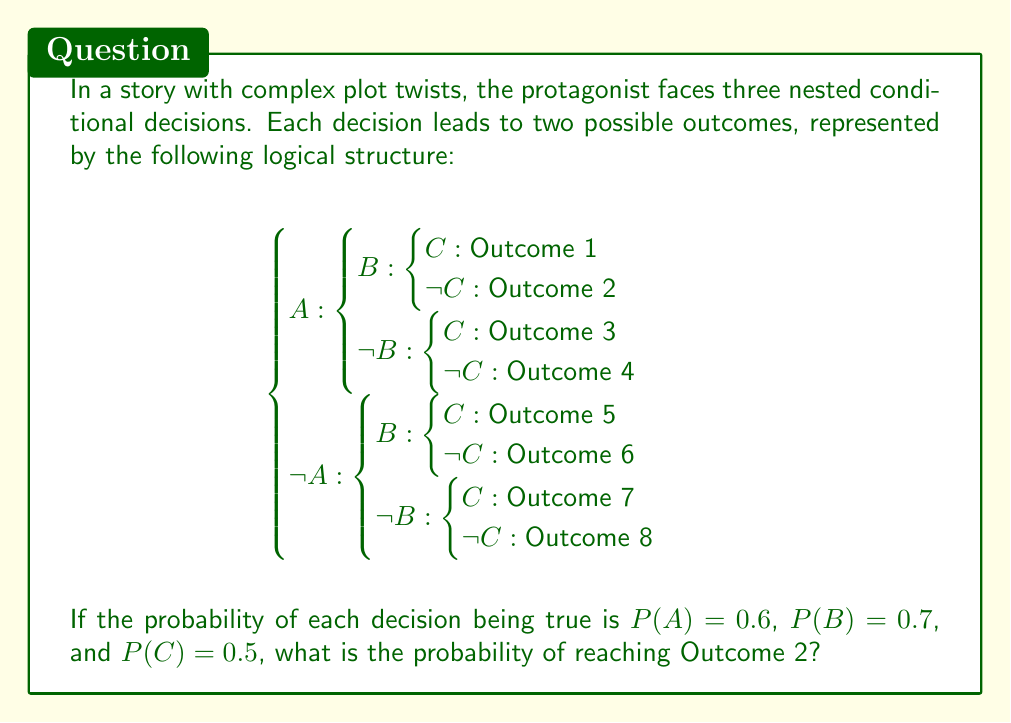Give your solution to this math problem. To find the probability of reaching Outcome 2, we need to follow the nested conditional structure and multiply the probabilities of each decision leading to that outcome.

Step 1: Identify the path to Outcome 2
Outcome 2 occurs when A is true, B is true, and C is false.

Step 2: Calculate the probability of each decision in the path
P(A) = 0.6 (given)
P(B) = 0.7 (given)
P(¬C) = 1 - P(C) = 1 - 0.5 = 0.5

Step 3: Multiply the probabilities to get the joint probability
P(Outcome 2) = P(A) × P(B) × P(¬C)
              = 0.6 × 0.7 × 0.5

Step 4: Perform the calculation
P(Outcome 2) = 0.6 × 0.7 × 0.5 = 0.21

Therefore, the probability of reaching Outcome 2 is 0.21 or 21%.
Answer: 0.21 